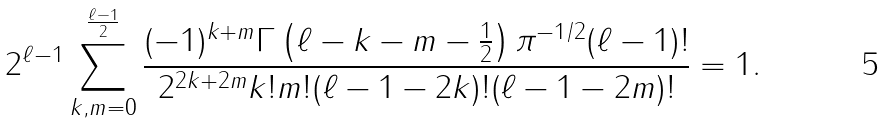<formula> <loc_0><loc_0><loc_500><loc_500>2 ^ { \ell - 1 } \sum _ { k , m = 0 } ^ { \frac { \ell - 1 } { 2 } } \frac { ( - 1 ) ^ { k + m } \Gamma \left ( \ell - k - m - \frac { 1 } { 2 } \right ) \pi ^ { - 1 / 2 } ( \ell - 1 ) ! } { 2 ^ { 2 k + 2 m } k ! m ! ( \ell - 1 - 2 k ) ! ( \ell - 1 - 2 m ) ! } = 1 .</formula> 